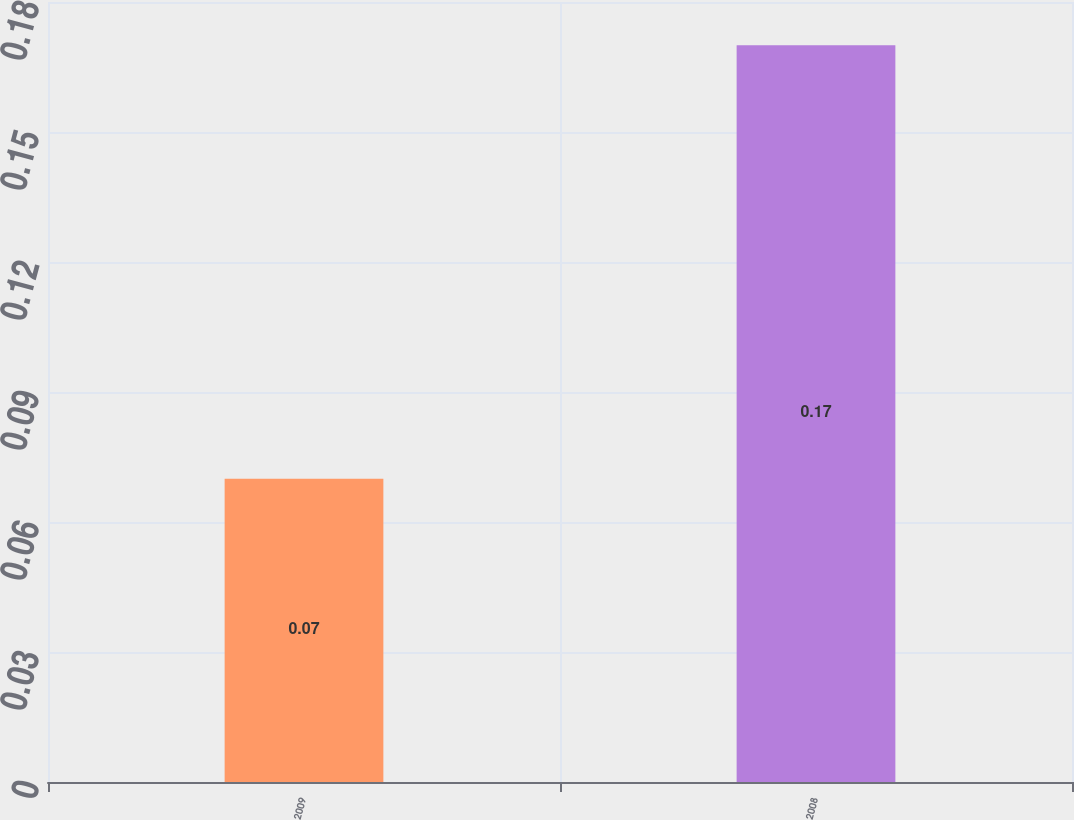<chart> <loc_0><loc_0><loc_500><loc_500><bar_chart><fcel>2009<fcel>2008<nl><fcel>0.07<fcel>0.17<nl></chart> 